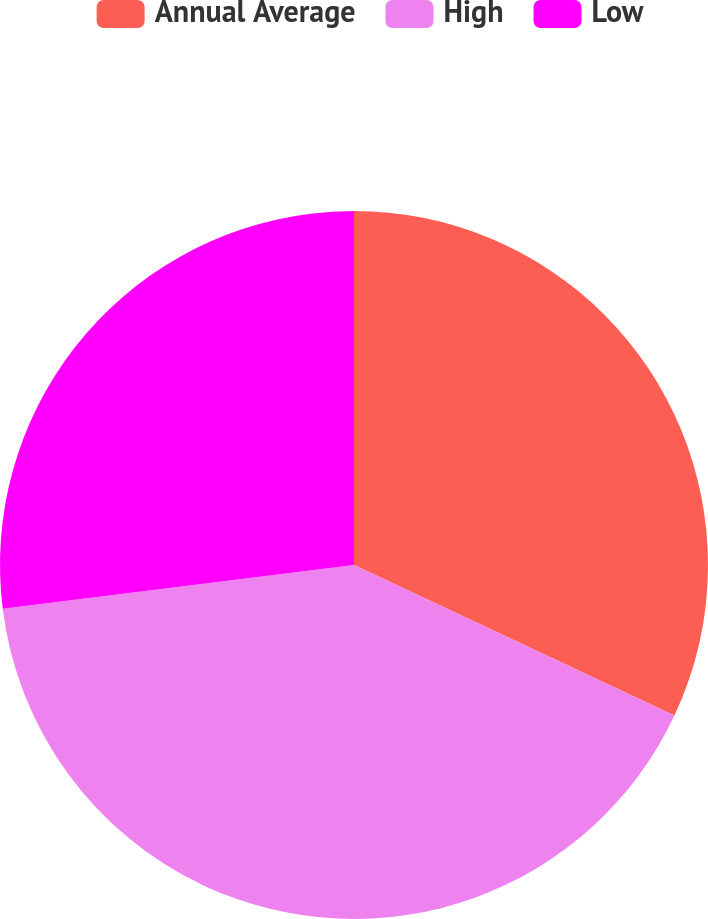Convert chart. <chart><loc_0><loc_0><loc_500><loc_500><pie_chart><fcel>Annual Average<fcel>High<fcel>Low<nl><fcel>31.99%<fcel>41.04%<fcel>26.97%<nl></chart> 